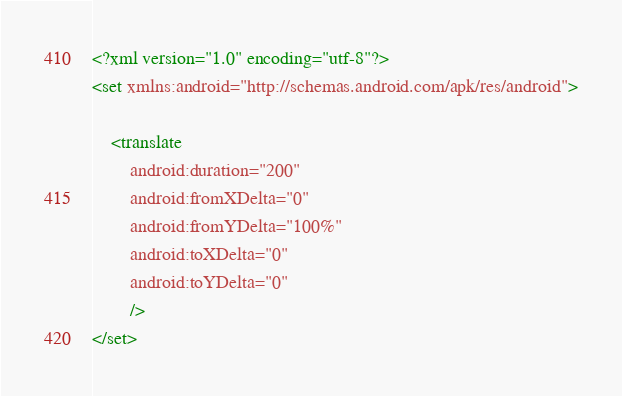<code> <loc_0><loc_0><loc_500><loc_500><_XML_><?xml version="1.0" encoding="utf-8"?>
<set xmlns:android="http://schemas.android.com/apk/res/android">

    <translate
        android:duration="200"
        android:fromXDelta="0"
        android:fromYDelta="100%"
        android:toXDelta="0"
        android:toYDelta="0"
        />
</set></code> 